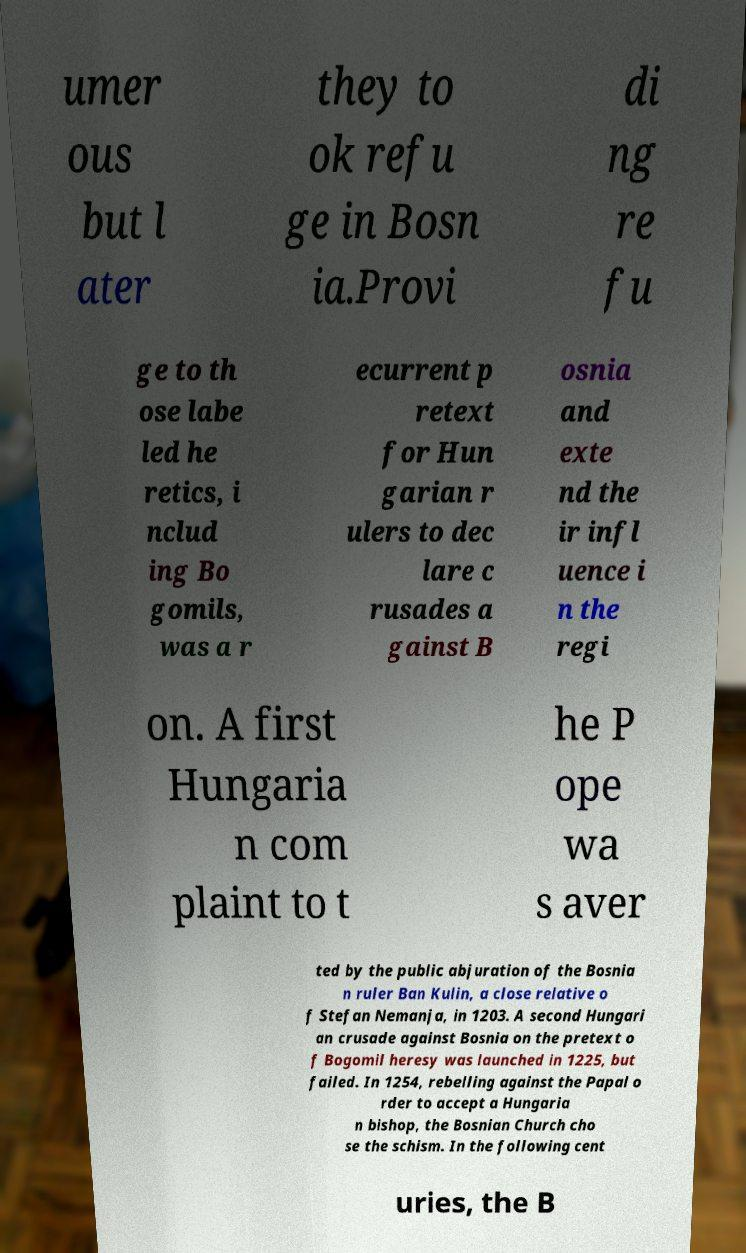I need the written content from this picture converted into text. Can you do that? umer ous but l ater they to ok refu ge in Bosn ia.Provi di ng re fu ge to th ose labe led he retics, i nclud ing Bo gomils, was a r ecurrent p retext for Hun garian r ulers to dec lare c rusades a gainst B osnia and exte nd the ir infl uence i n the regi on. A first Hungaria n com plaint to t he P ope wa s aver ted by the public abjuration of the Bosnia n ruler Ban Kulin, a close relative o f Stefan Nemanja, in 1203. A second Hungari an crusade against Bosnia on the pretext o f Bogomil heresy was launched in 1225, but failed. In 1254, rebelling against the Papal o rder to accept a Hungaria n bishop, the Bosnian Church cho se the schism. In the following cent uries, the B 